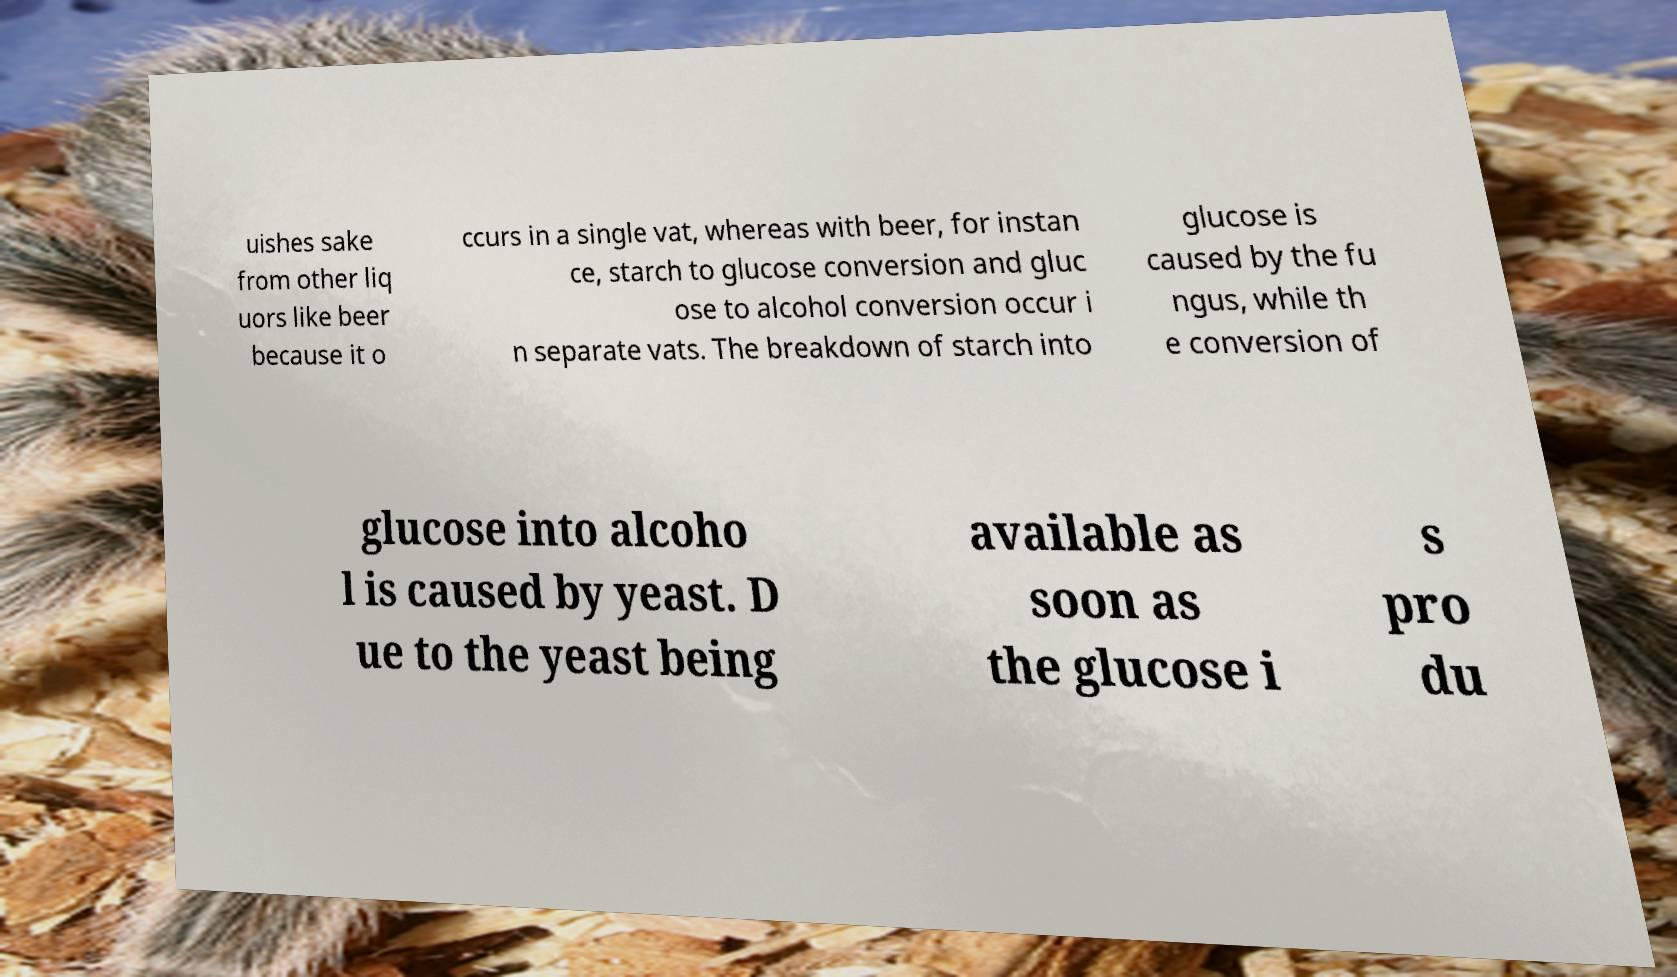Can you read and provide the text displayed in the image?This photo seems to have some interesting text. Can you extract and type it out for me? uishes sake from other liq uors like beer because it o ccurs in a single vat, whereas with beer, for instan ce, starch to glucose conversion and gluc ose to alcohol conversion occur i n separate vats. The breakdown of starch into glucose is caused by the fu ngus, while th e conversion of glucose into alcoho l is caused by yeast. D ue to the yeast being available as soon as the glucose i s pro du 